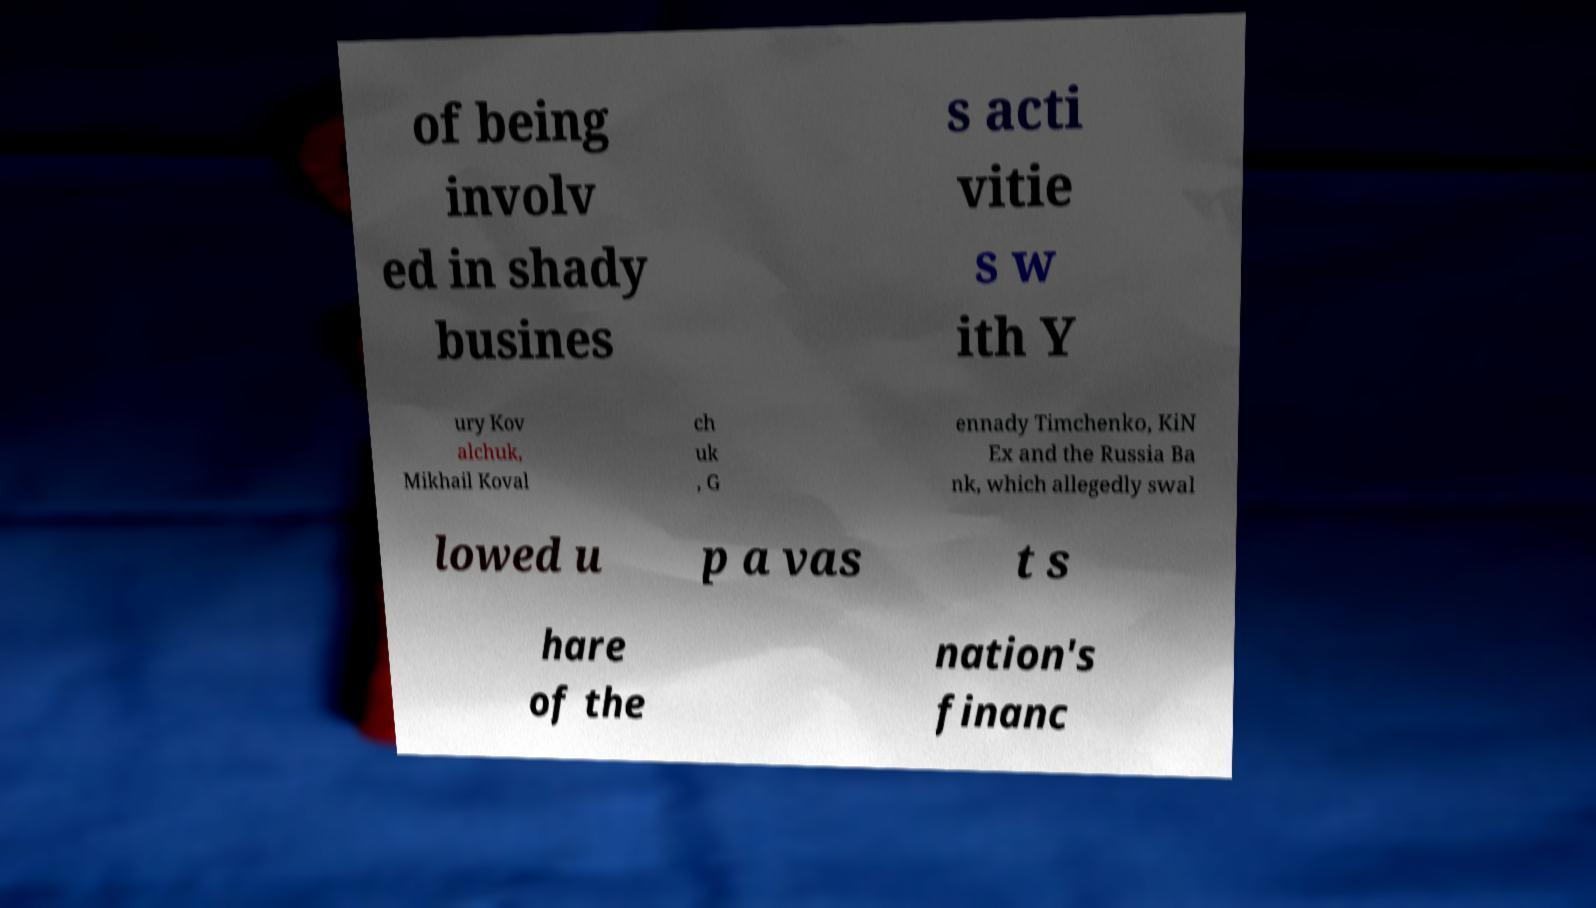Please identify and transcribe the text found in this image. of being involv ed in shady busines s acti vitie s w ith Y ury Kov alchuk, Mikhail Koval ch uk , G ennady Timchenko, KiN Ex and the Russia Ba nk, which allegedly swal lowed u p a vas t s hare of the nation's financ 